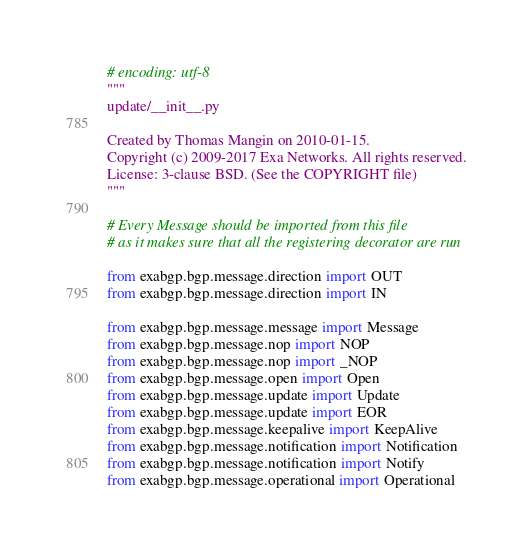Convert code to text. <code><loc_0><loc_0><loc_500><loc_500><_Python_># encoding: utf-8
"""
update/__init__.py

Created by Thomas Mangin on 2010-01-15.
Copyright (c) 2009-2017 Exa Networks. All rights reserved.
License: 3-clause BSD. (See the COPYRIGHT file)
"""

# Every Message should be imported from this file
# as it makes sure that all the registering decorator are run

from exabgp.bgp.message.direction import OUT
from exabgp.bgp.message.direction import IN

from exabgp.bgp.message.message import Message
from exabgp.bgp.message.nop import NOP
from exabgp.bgp.message.nop import _NOP
from exabgp.bgp.message.open import Open
from exabgp.bgp.message.update import Update
from exabgp.bgp.message.update import EOR
from exabgp.bgp.message.keepalive import KeepAlive
from exabgp.bgp.message.notification import Notification
from exabgp.bgp.message.notification import Notify
from exabgp.bgp.message.operational import Operational
</code> 